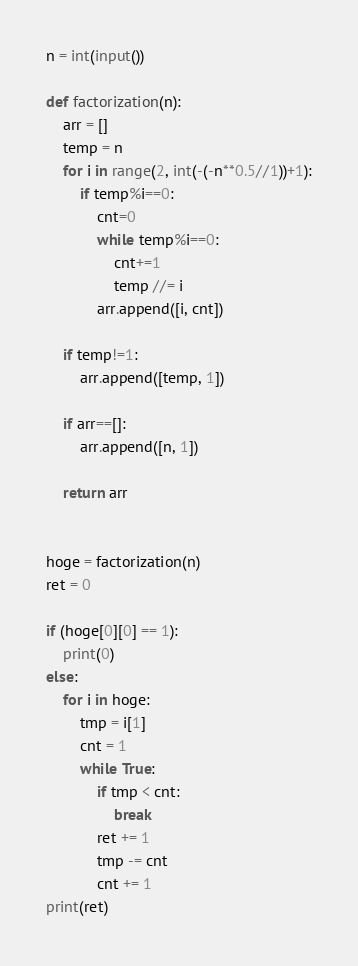<code> <loc_0><loc_0><loc_500><loc_500><_Python_>n = int(input())

def factorization(n):
    arr = []
    temp = n
    for i in range(2, int(-(-n**0.5//1))+1):
        if temp%i==0:
            cnt=0
            while temp%i==0:
                cnt+=1
                temp //= i
            arr.append([i, cnt])

    if temp!=1:
        arr.append([temp, 1])

    if arr==[]:
        arr.append([n, 1])

    return arr


hoge = factorization(n)
ret = 0

if (hoge[0][0] == 1):
    print(0)
else:
    for i in hoge:
        tmp = i[1]
        cnt = 1
        while True:
            if tmp < cnt:
                break
            ret += 1
            tmp -= cnt
            cnt += 1
print(ret)
</code> 